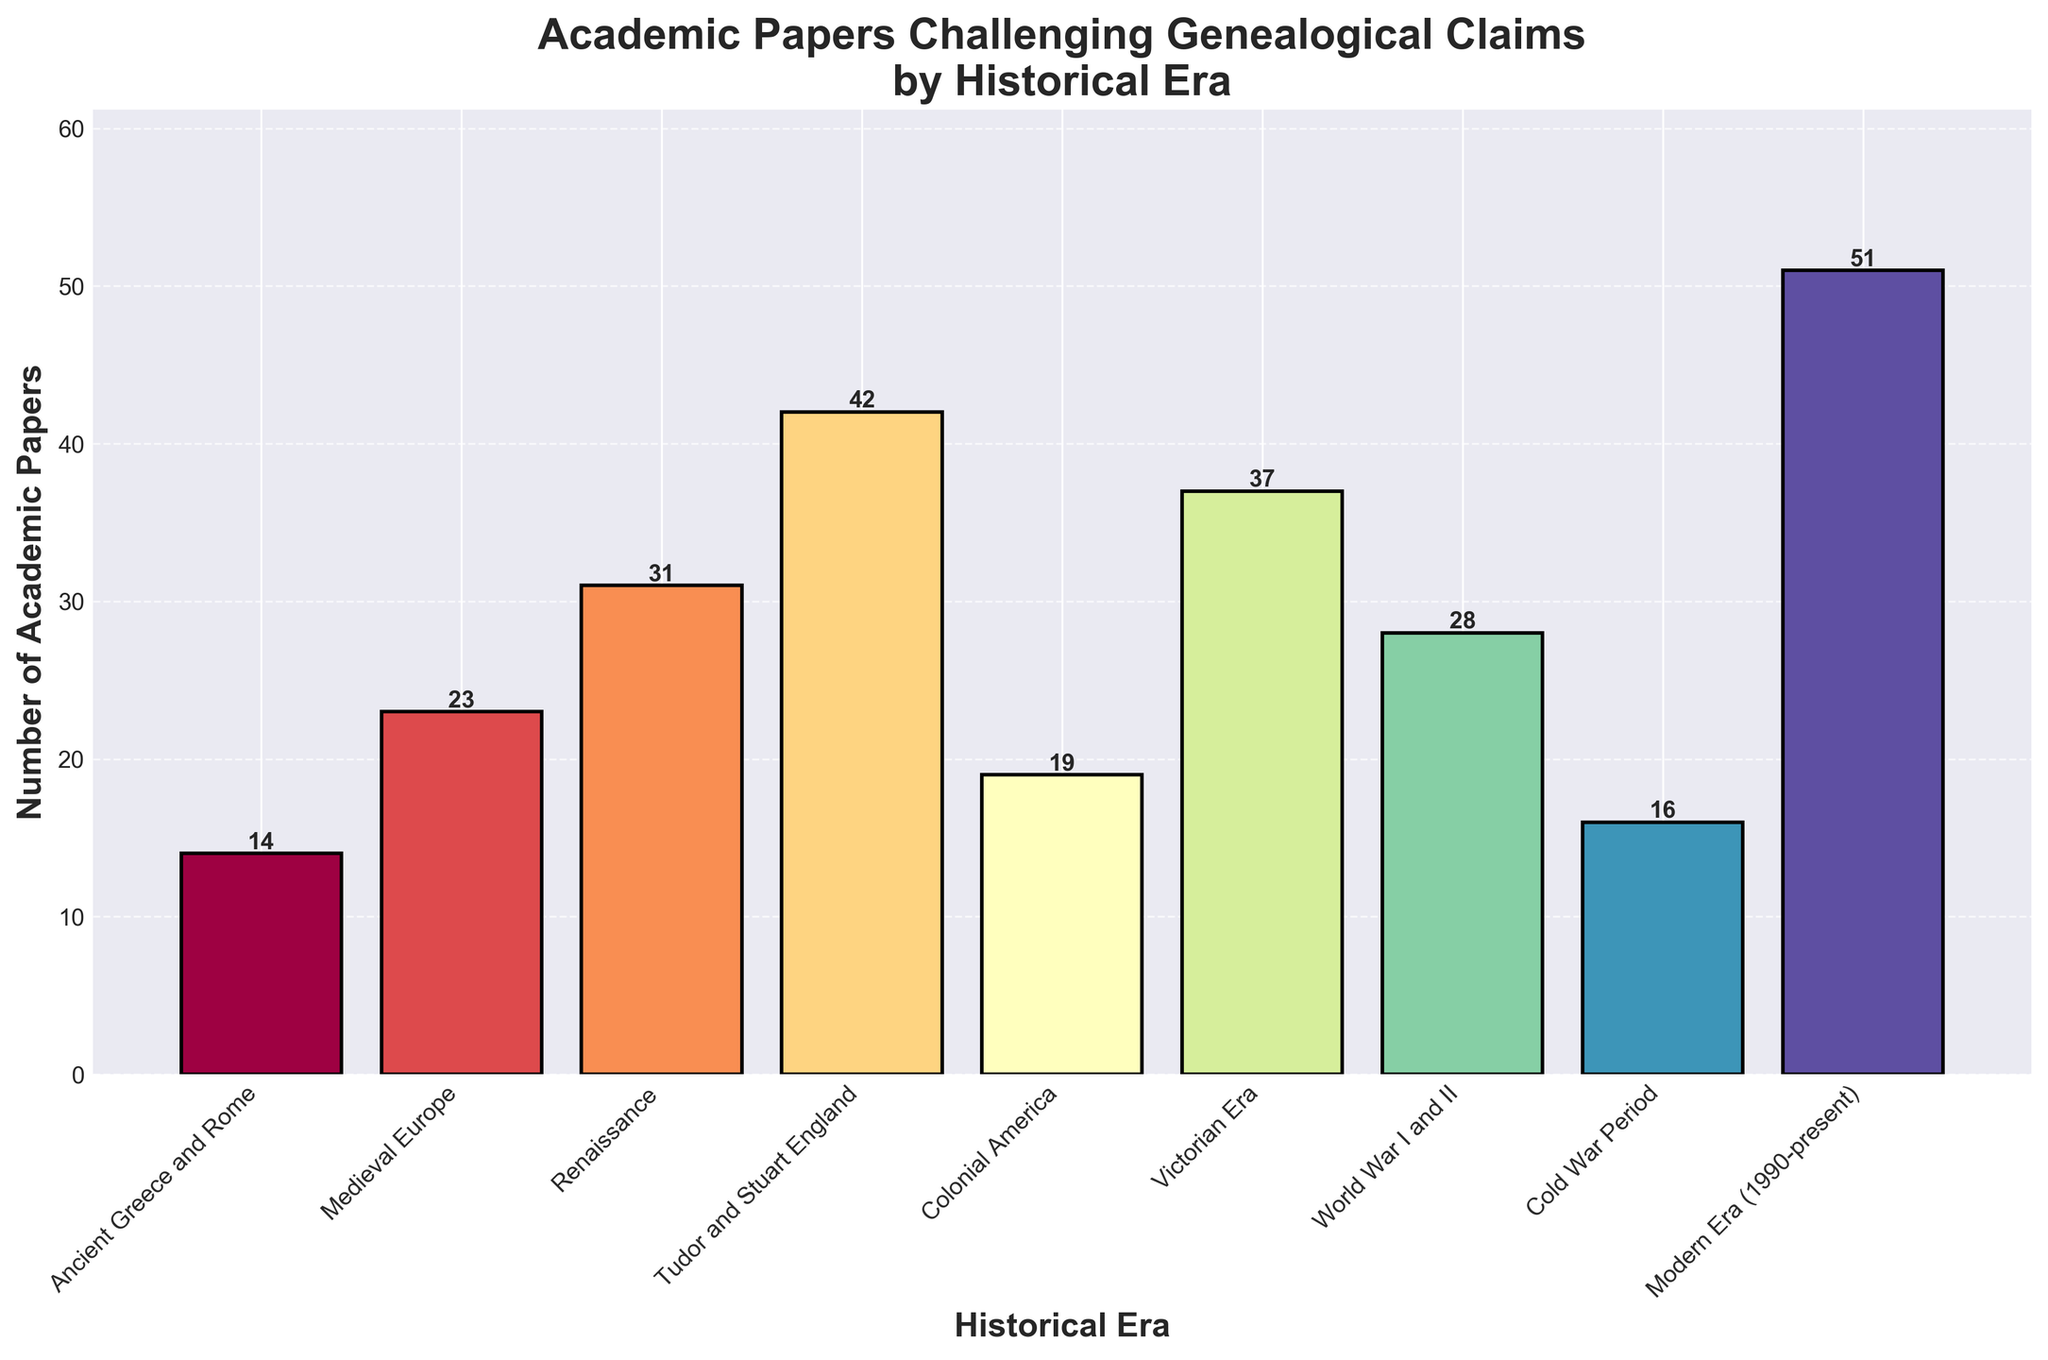Which historical era has the highest number of academic papers challenging genealogical claims? The bar for Modern Era (1990-present) is the tallest, indicating the highest number of academic papers.
Answer: Modern Era (1990-present) How many more academic papers were published in the Renaissance era than in Colonial America? The number of papers for the Renaissance is 31, and for Colonial America, it is 19. The difference is 31 - 19.
Answer: 12 Which era had fewer academic papers published, the Victorian Era or World War I and II? The bar for World War I and II is shorter (28 papers) compared to the bar for the Victorian Era (37 papers).
Answer: World War I and II What is the combined total number of academic papers for Medieval Europe and Tudor and Stuart England? Medieval Europe has 23 papers, and Tudor and Stuart England has 42 papers. The combined total is 23 + 42.
Answer: 65 By how much does the number of academic papers in the Modern Era exceed the number in the Tudor and Stuart England era? The number of papers in the Modern Era is 51, and in the Tudor and Stuart England era, it is 42. The excess is 51 - 42.
Answer: 9 What is the average number of academic papers for the Ancient Greece and Rome, Medieval Europe, and Renaissance eras? The sum of papers for these eras is 14 (Ancient Greece and Rome) + 23 (Medieval Europe) + 31 (Renaissance) = 68. The average is 68 / 3.
Answer: 22.67 Which historical era is represented by the darkest color bar? The colors are not explicitly listed, but typically in sequential colormaps, the farthest chronological point (Modern Era) would be represented by the darkest color.
Answer: Modern Era (1990-present) What is the median number of academic papers across all historical eras? The sorted number of papers is [14, 16, 19, 23, 28, 31, 37, 42, 51], and the middle value is 28.
Answer: 28 Which two consecutive historical eras have the smallest difference in the number of academic papers? The differences between consecutive eras are: 
(Medieval Europe - Ancient Greece and Rome) = 9, 
(Renaissance - Medieval Europe) = 8, 
(Tudor and Stuart England - Renaissance) = 11, 
(Colonial America - Tudor and Stuart England) = 23, 
(Victorian Era - Colonial America) = 18, 
(World War I and II - Victorian Era) = 9, 
(Cold War Period - World War I and II) = 12, 
(Modern Era - Cold War Period) = 35.
The smallest difference is 8.
Answer: Renaissance and Medieval Europe 